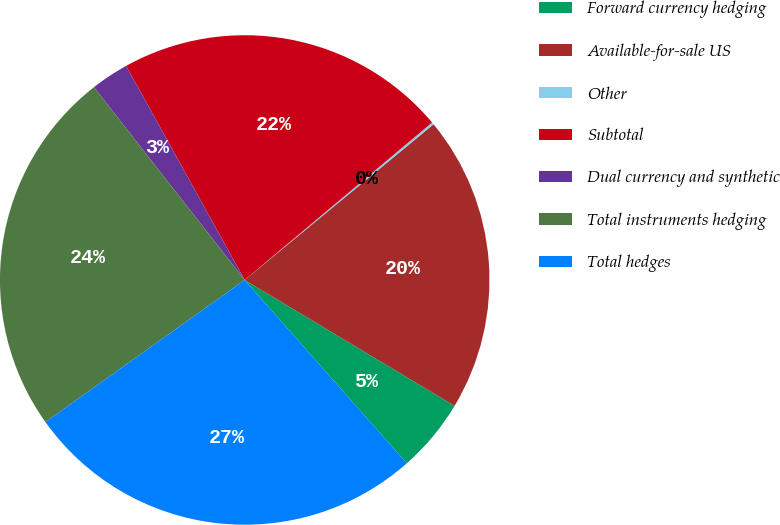<chart> <loc_0><loc_0><loc_500><loc_500><pie_chart><fcel>Forward currency hedging<fcel>Available-for-sale US<fcel>Other<fcel>Subtotal<fcel>Dual currency and synthetic<fcel>Total instruments hedging<fcel>Total hedges<nl><fcel>4.88%<fcel>19.57%<fcel>0.15%<fcel>21.93%<fcel>2.51%<fcel>24.3%<fcel>26.66%<nl></chart> 